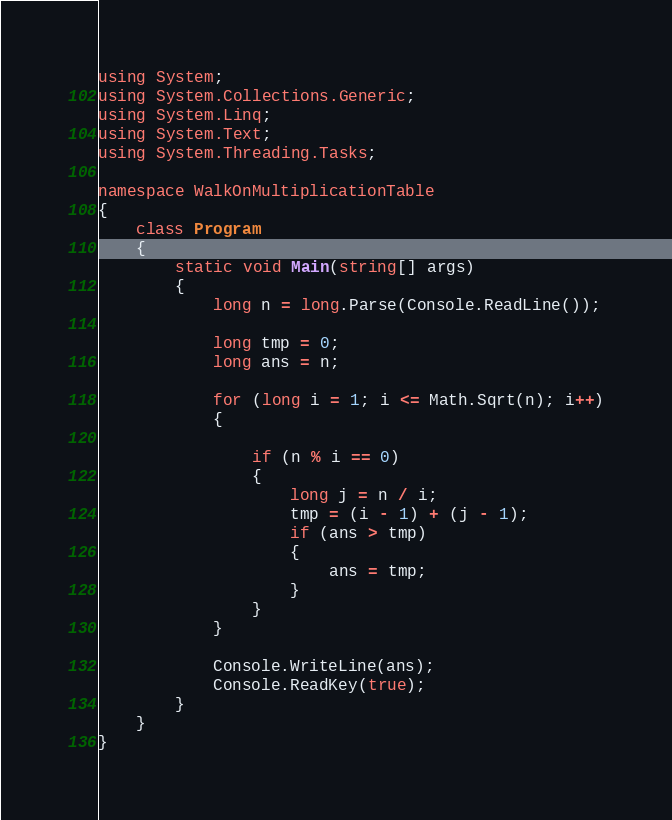Convert code to text. <code><loc_0><loc_0><loc_500><loc_500><_C#_>using System;
using System.Collections.Generic;
using System.Linq;
using System.Text;
using System.Threading.Tasks;

namespace WalkOnMultiplicationTable
{
    class Program
    {
        static void Main(string[] args)
        {
            long n = long.Parse(Console.ReadLine());

            long tmp = 0;
            long ans = n;
            
            for (long i = 1; i <= Math.Sqrt(n); i++)
            {

                if (n % i == 0)
                {
                    long j = n / i;
                    tmp = (i - 1) + (j - 1);
                    if (ans > tmp)
                    {
                        ans = tmp;
                    }
                }
            }

            Console.WriteLine(ans);
            Console.ReadKey(true);
        }
    }
}
</code> 